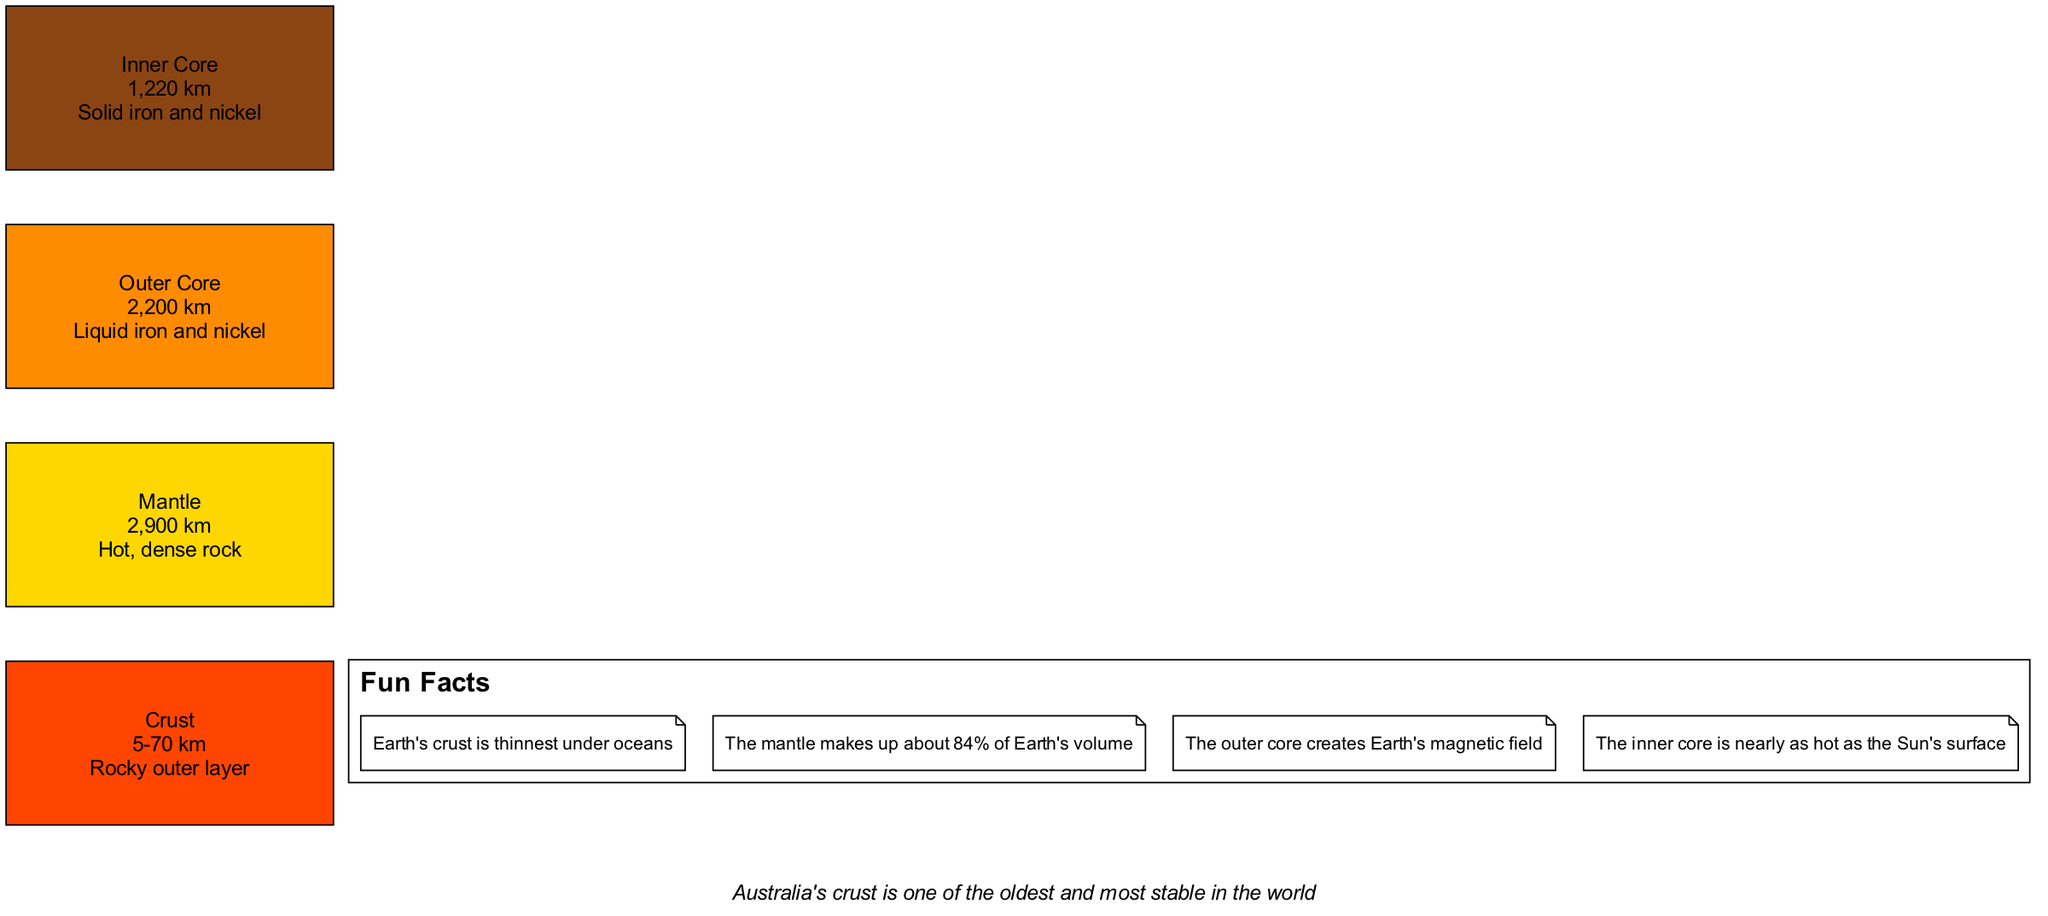What is the thickness range of the Crust? The diagram states that the Crust has a thickness range of 5-70 km. This information is found directly in the description under the Crust layer.
Answer: 5-70 km What is the material composition of the Outer Core? The description of the Outer Core clearly states that it is made of liquid iron and nickel. This is explicitly mentioned in the diagram's text.
Answer: Liquid iron and nickel How many layers are depicted in the diagram? By counting each layer from the diagram (Crust, Mantle, Outer Core, and Inner Core), we identify four distinct layers.
Answer: 4 Which layer makes up about 84% of Earth's volume? The diagram contains a fun fact stating that the Mantle makes up about 84% of Earth's volume. Thus, this information can be directly referenced.
Answer: Mantle Is the Inner Core solid or liquid? The description of the Inner Core in the diagram states that it is solid. This clearly shows the form of the Inner Core.
Answer: Solid How thick is the Mantle? The diagram indicates that the Mantle has a thickness of 2,900 km, as directly stated in the description of this layer.
Answer: 2,900 km What interesting fact is associated with the Earth's crust? According to the fun facts section, one interesting fact is that the Earth's crust is thinnest under oceans, which is clearly conveyed.
Answer: Thinnest under oceans Why does the Outer Core contribute to Earth's magnetic field? The diagram notes that the Outer Core creates Earth's magnetic field. This indicates that the movement of liquid iron and nickel is responsible for this phenomenon, as mentioned in the diagram content.
Answer: It creates Earth's magnetic field What is unique about Australia’s crust according to the diagram? The Australian context section states that Australia's crust is one of the oldest and most stable in the world, which is a unique characteristic highlighted in the diagram.
Answer: Oldest and most stable 